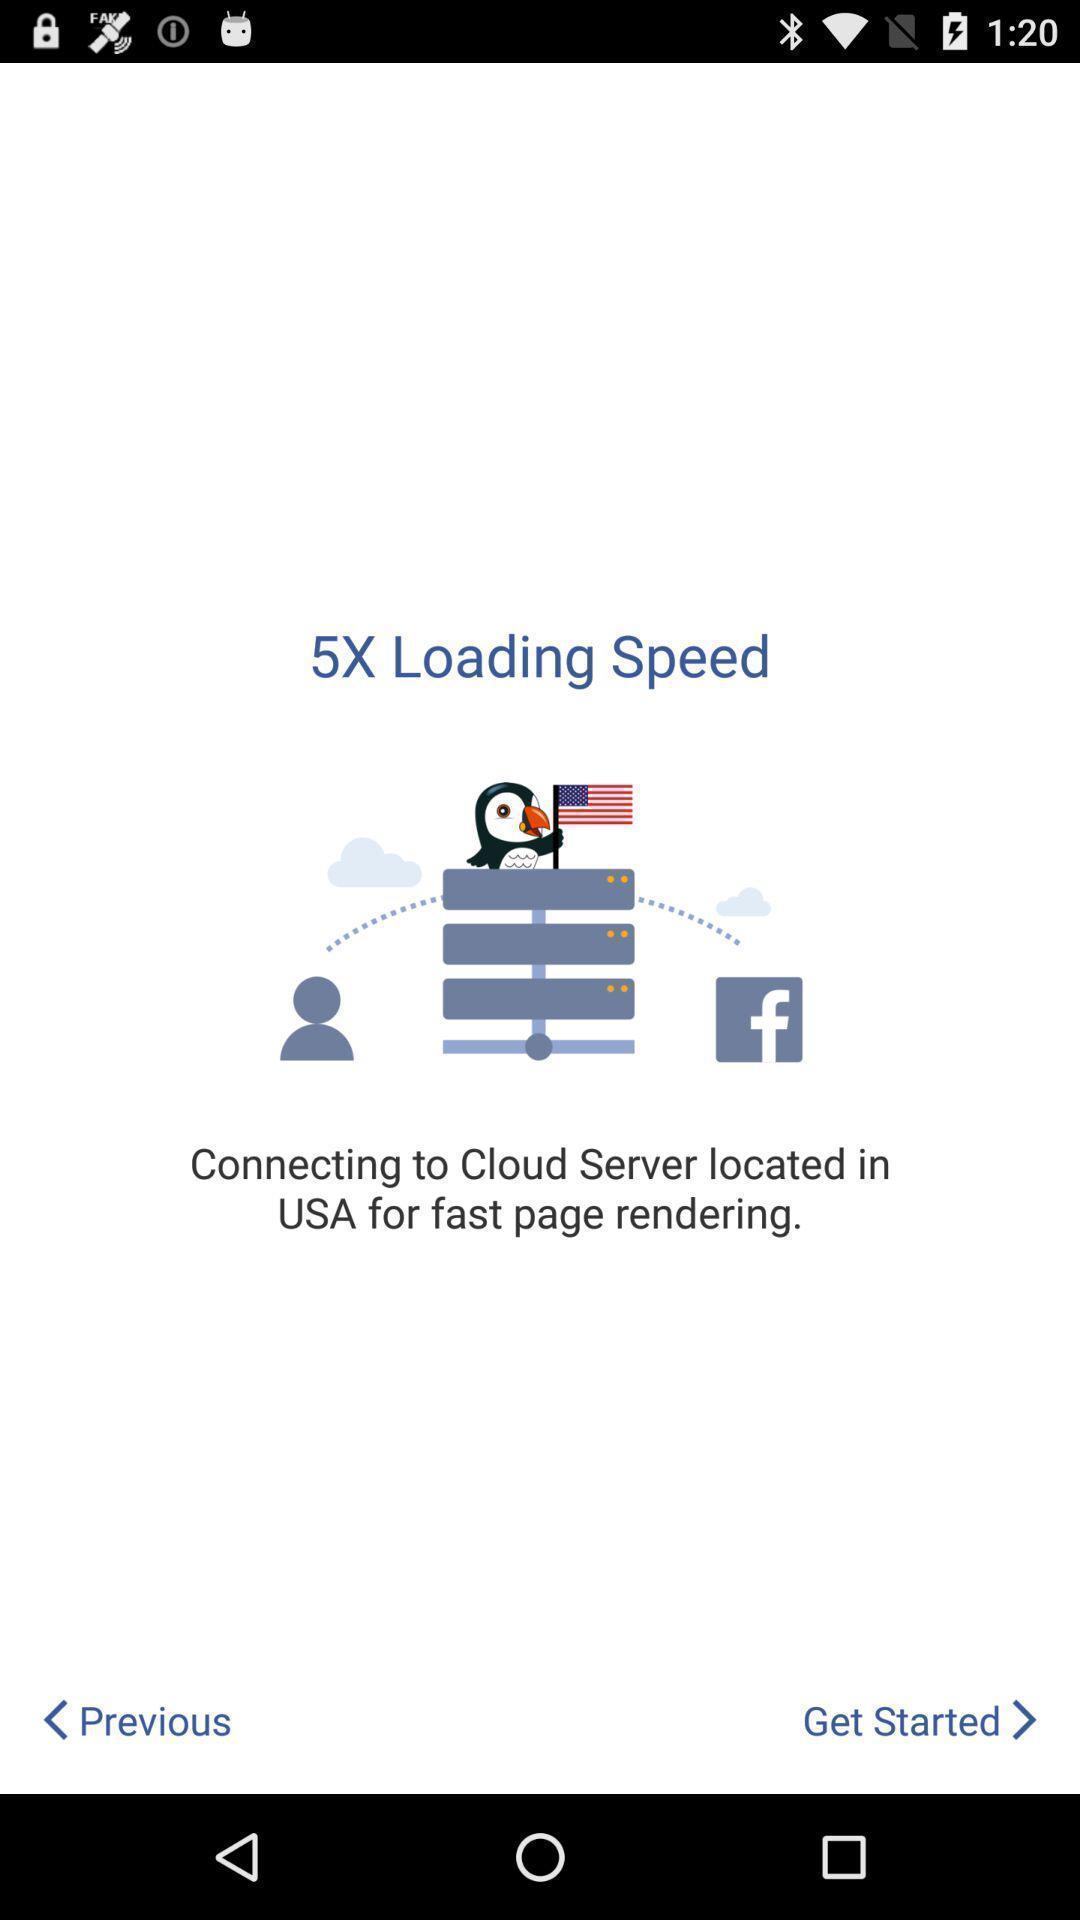Summarize the information in this screenshot. Welcome page showing get started and previous options in app. 